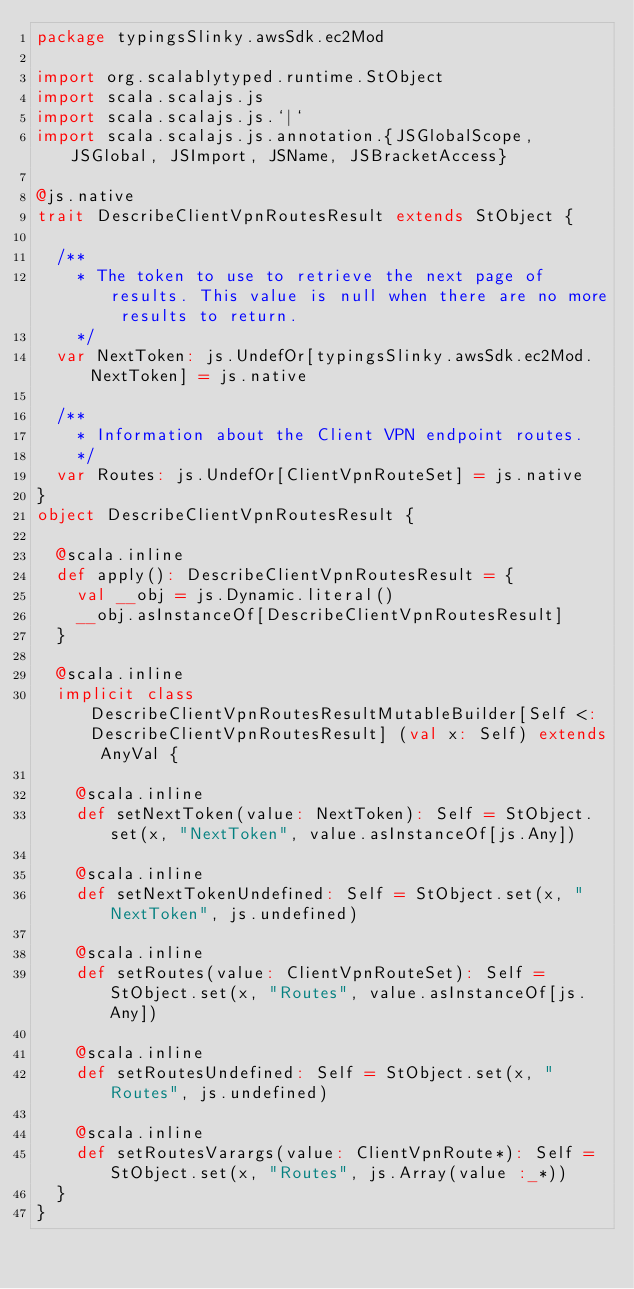<code> <loc_0><loc_0><loc_500><loc_500><_Scala_>package typingsSlinky.awsSdk.ec2Mod

import org.scalablytyped.runtime.StObject
import scala.scalajs.js
import scala.scalajs.js.`|`
import scala.scalajs.js.annotation.{JSGlobalScope, JSGlobal, JSImport, JSName, JSBracketAccess}

@js.native
trait DescribeClientVpnRoutesResult extends StObject {
  
  /**
    * The token to use to retrieve the next page of results. This value is null when there are no more results to return.
    */
  var NextToken: js.UndefOr[typingsSlinky.awsSdk.ec2Mod.NextToken] = js.native
  
  /**
    * Information about the Client VPN endpoint routes.
    */
  var Routes: js.UndefOr[ClientVpnRouteSet] = js.native
}
object DescribeClientVpnRoutesResult {
  
  @scala.inline
  def apply(): DescribeClientVpnRoutesResult = {
    val __obj = js.Dynamic.literal()
    __obj.asInstanceOf[DescribeClientVpnRoutesResult]
  }
  
  @scala.inline
  implicit class DescribeClientVpnRoutesResultMutableBuilder[Self <: DescribeClientVpnRoutesResult] (val x: Self) extends AnyVal {
    
    @scala.inline
    def setNextToken(value: NextToken): Self = StObject.set(x, "NextToken", value.asInstanceOf[js.Any])
    
    @scala.inline
    def setNextTokenUndefined: Self = StObject.set(x, "NextToken", js.undefined)
    
    @scala.inline
    def setRoutes(value: ClientVpnRouteSet): Self = StObject.set(x, "Routes", value.asInstanceOf[js.Any])
    
    @scala.inline
    def setRoutesUndefined: Self = StObject.set(x, "Routes", js.undefined)
    
    @scala.inline
    def setRoutesVarargs(value: ClientVpnRoute*): Self = StObject.set(x, "Routes", js.Array(value :_*))
  }
}
</code> 